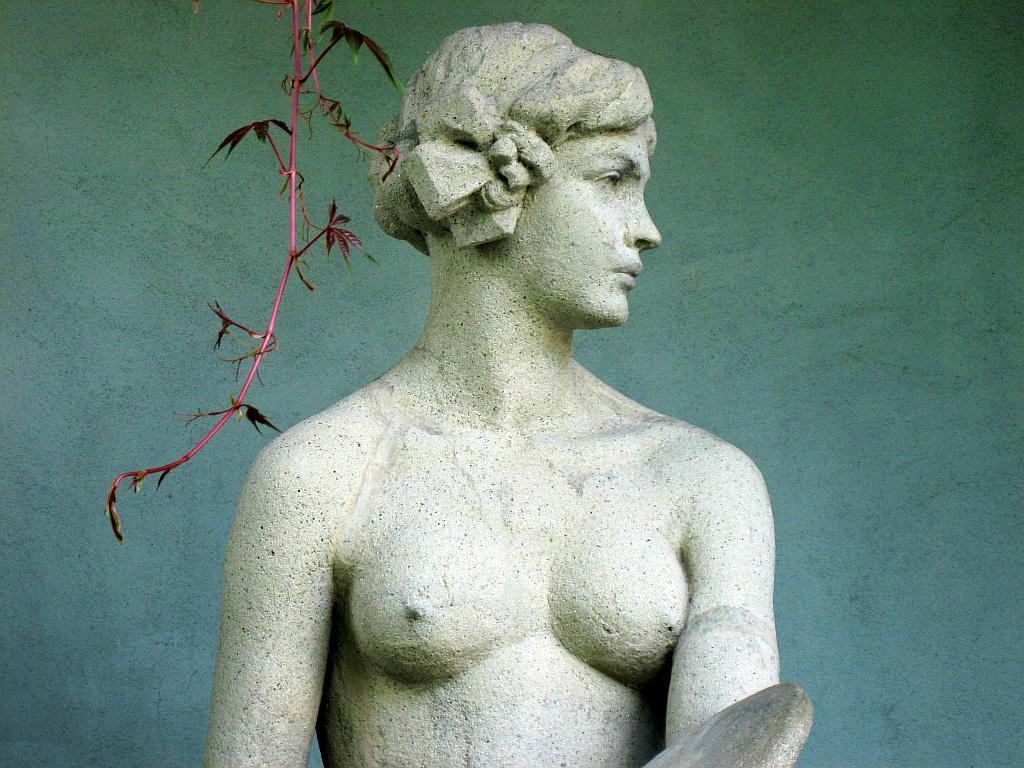Describe this image in one or two sentences. In the center of the image we can see a sculpture. At the top there is a stem. In the background we can see a wall. 